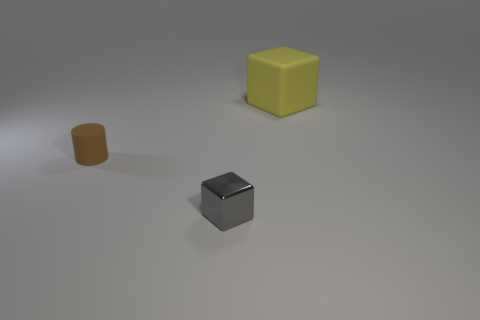Add 3 tiny cyan matte blocks. How many objects exist? 6 Subtract all cubes. How many objects are left? 1 Add 2 rubber cylinders. How many rubber cylinders exist? 3 Subtract 0 green spheres. How many objects are left? 3 Subtract all rubber cylinders. Subtract all yellow things. How many objects are left? 1 Add 2 big matte objects. How many big matte objects are left? 3 